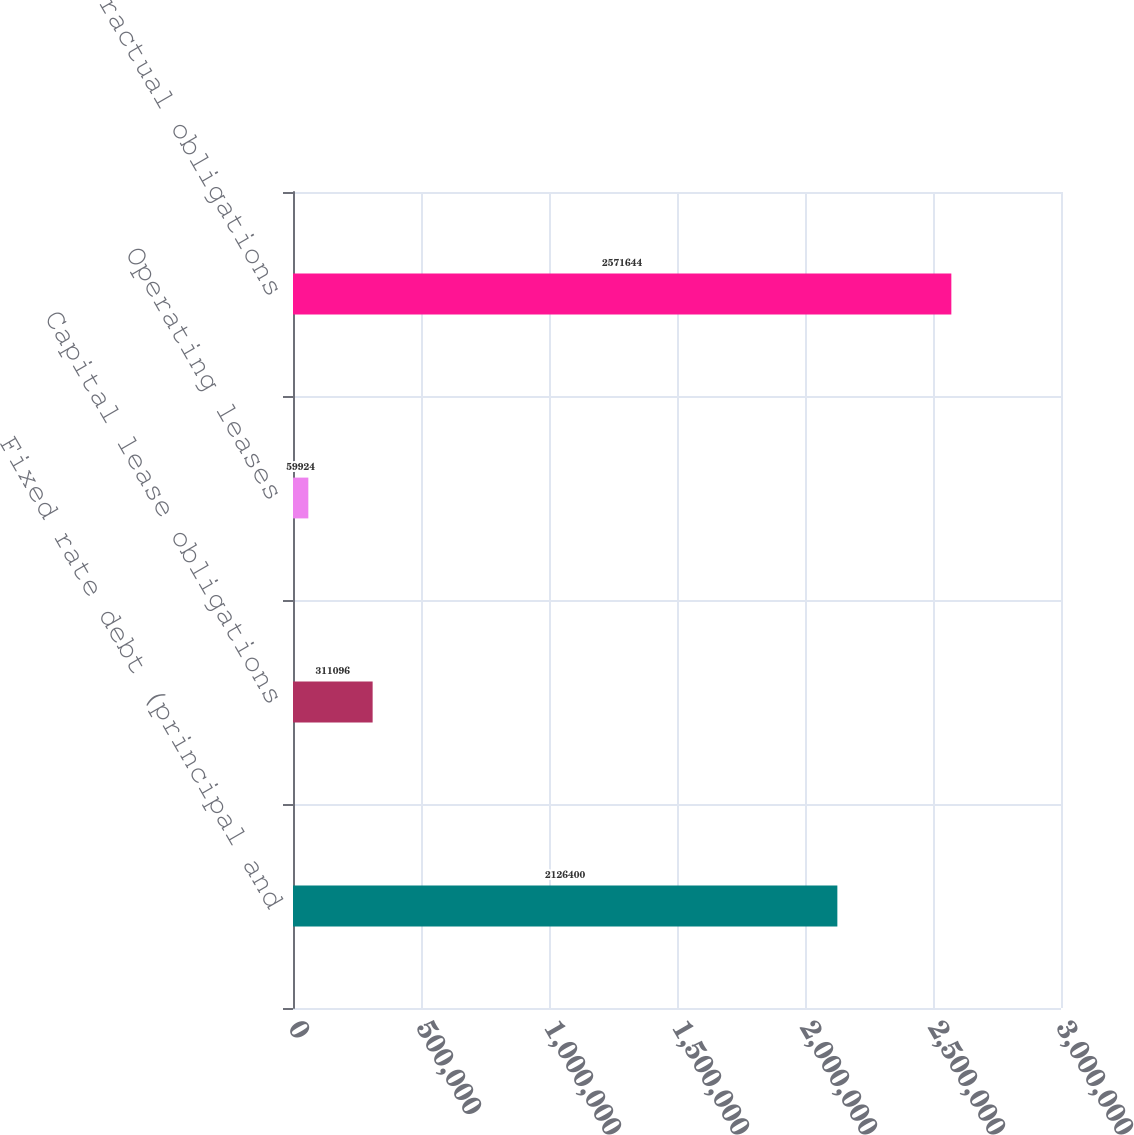Convert chart to OTSL. <chart><loc_0><loc_0><loc_500><loc_500><bar_chart><fcel>Fixed rate debt (principal and<fcel>Capital lease obligations<fcel>Operating leases<fcel>Total contractual obligations<nl><fcel>2.1264e+06<fcel>311096<fcel>59924<fcel>2.57164e+06<nl></chart> 